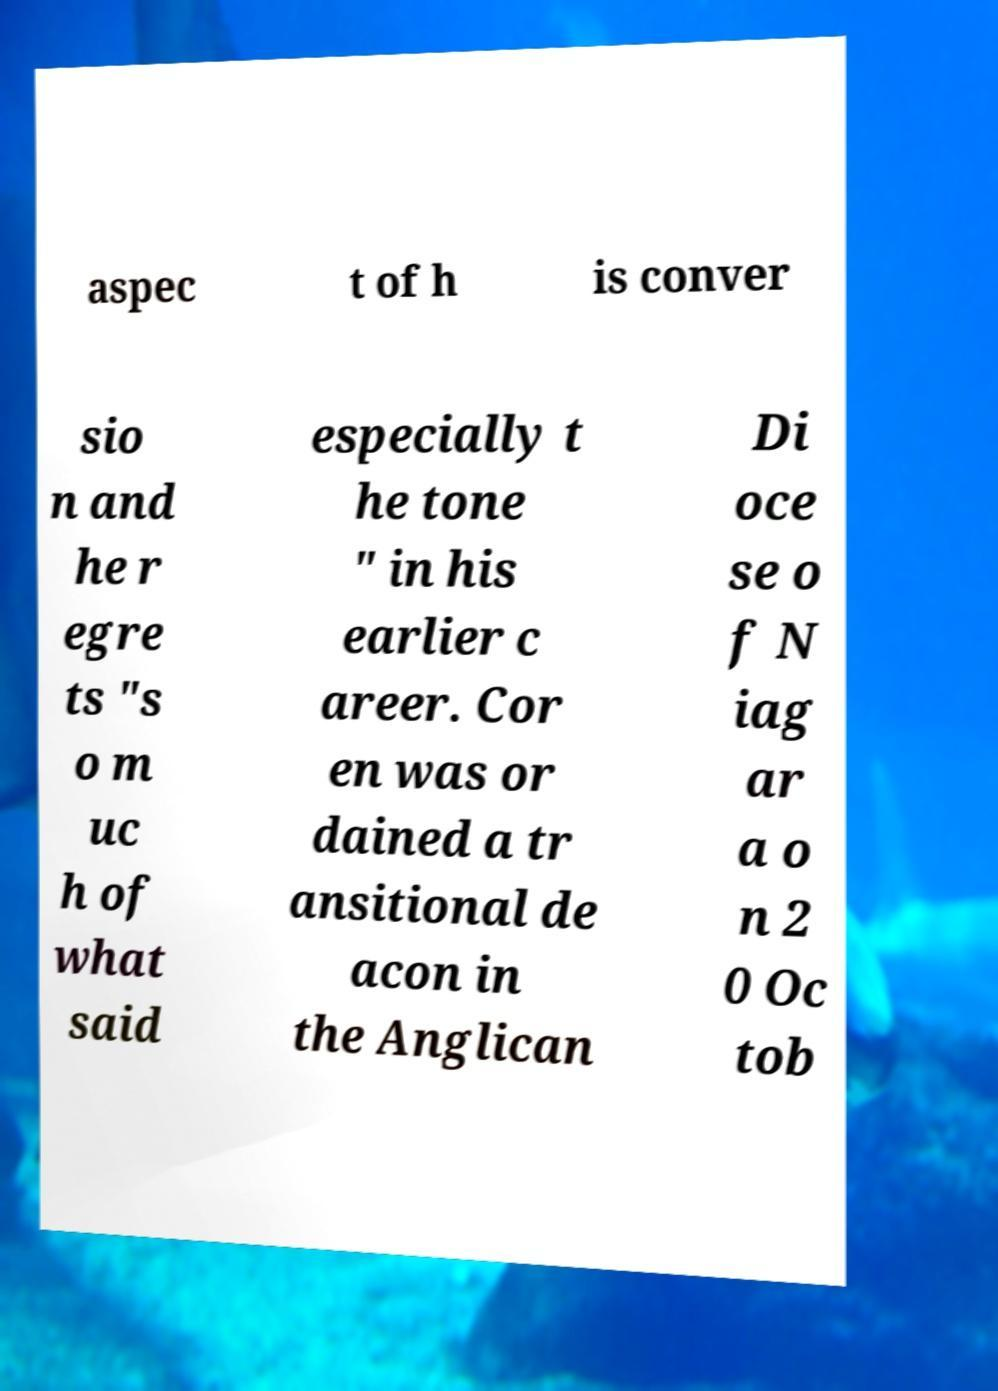There's text embedded in this image that I need extracted. Can you transcribe it verbatim? aspec t of h is conver sio n and he r egre ts "s o m uc h of what said especially t he tone " in his earlier c areer. Cor en was or dained a tr ansitional de acon in the Anglican Di oce se o f N iag ar a o n 2 0 Oc tob 